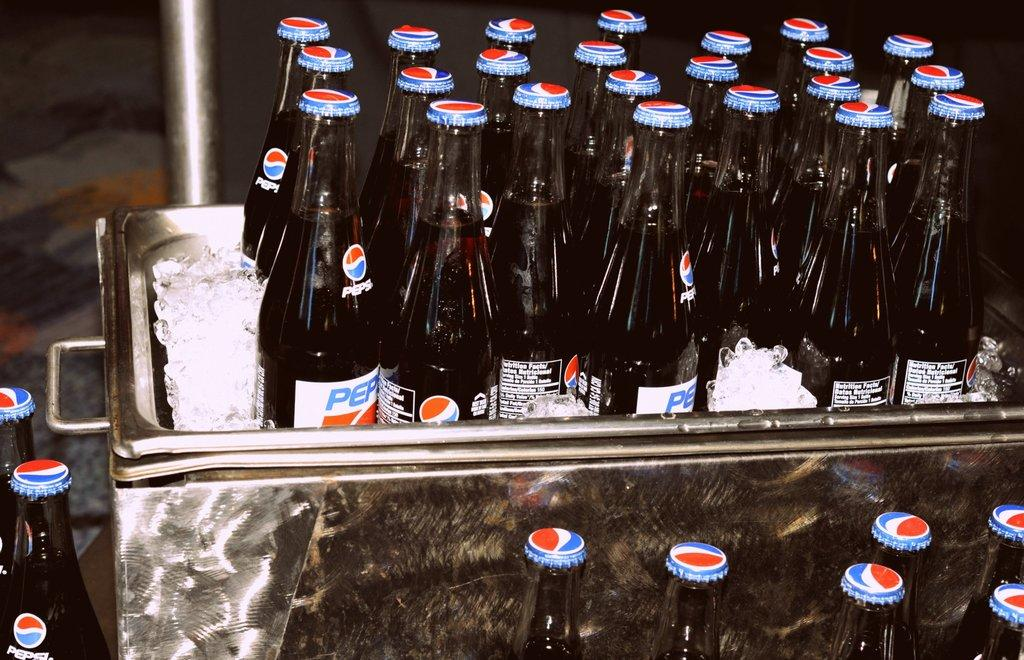<image>
Write a terse but informative summary of the picture. Old fashioned pepsi's in the bottles with the screw off lids sitting in a silver cooler on ice. 